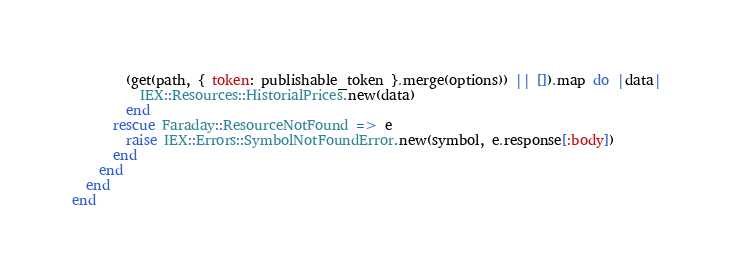Convert code to text. <code><loc_0><loc_0><loc_500><loc_500><_Ruby_>        (get(path, { token: publishable_token }.merge(options)) || []).map do |data|
          IEX::Resources::HistorialPrices.new(data)
        end
      rescue Faraday::ResourceNotFound => e
        raise IEX::Errors::SymbolNotFoundError.new(symbol, e.response[:body])
      end
    end
  end
end
</code> 